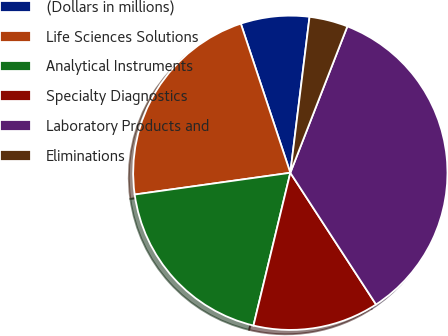Convert chart to OTSL. <chart><loc_0><loc_0><loc_500><loc_500><pie_chart><fcel>(Dollars in millions)<fcel>Life Sciences Solutions<fcel>Analytical Instruments<fcel>Specialty Diagnostics<fcel>Laboratory Products and<fcel>Eliminations<nl><fcel>7.05%<fcel>22.11%<fcel>19.02%<fcel>12.95%<fcel>34.9%<fcel>3.96%<nl></chart> 